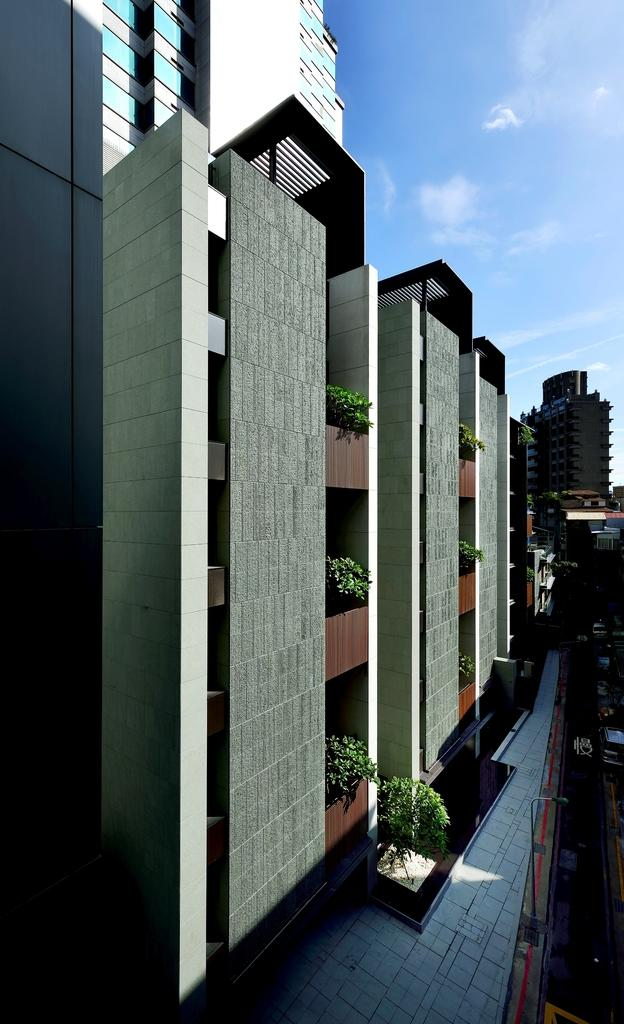What type of structures can be seen in the image? There are buildings in the image. What other elements are present in the image besides the buildings? There are plants in the image. Where are the plants located in relation to the buildings? The plants are located in the middle of the image. What type of ear can be seen on the train in the image? There is no train or ear present in the image; it features buildings and plants. 